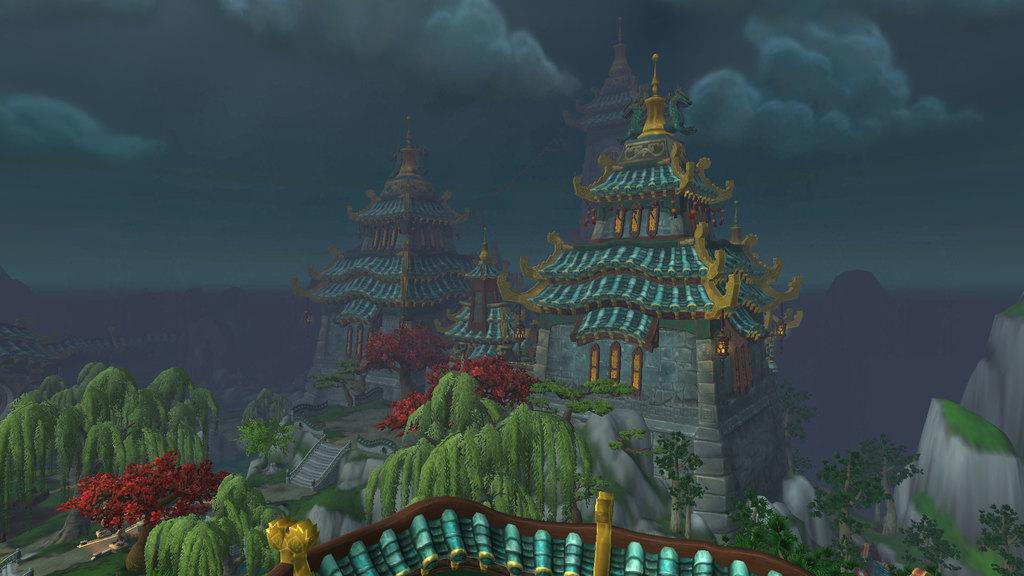What type of artwork is depicted in the image? The image is a painting. Are there any other paintings within the painting? Yes, there are paintings within the painting. What type of structure can be seen in the painting? There is a building in the painting. What architectural feature is present in front of the building? There are steps in front of the building. What type of vegetation is present in the painting? There are trees and flowering plants in the painting. What can be seen in the background of the painting? The sky is visible in the background of the painting, and there are clouds in the sky. How many planes are flying over the building in the painting? There are no planes visible in the painting; it only features a building, steps, trees, flowering plants, and the sky. 